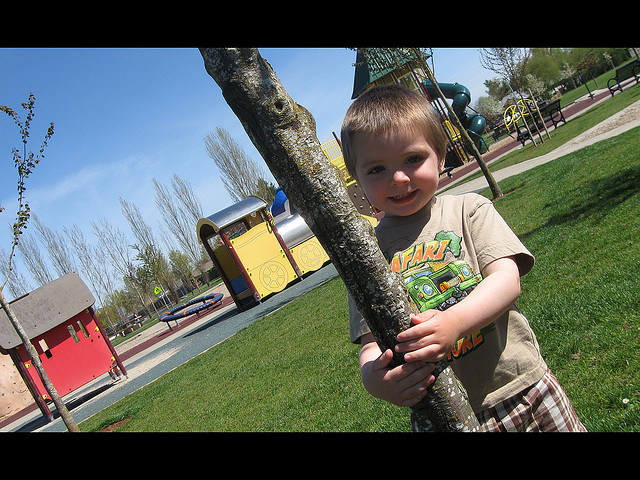Identify the text contained in this image. AFARI 